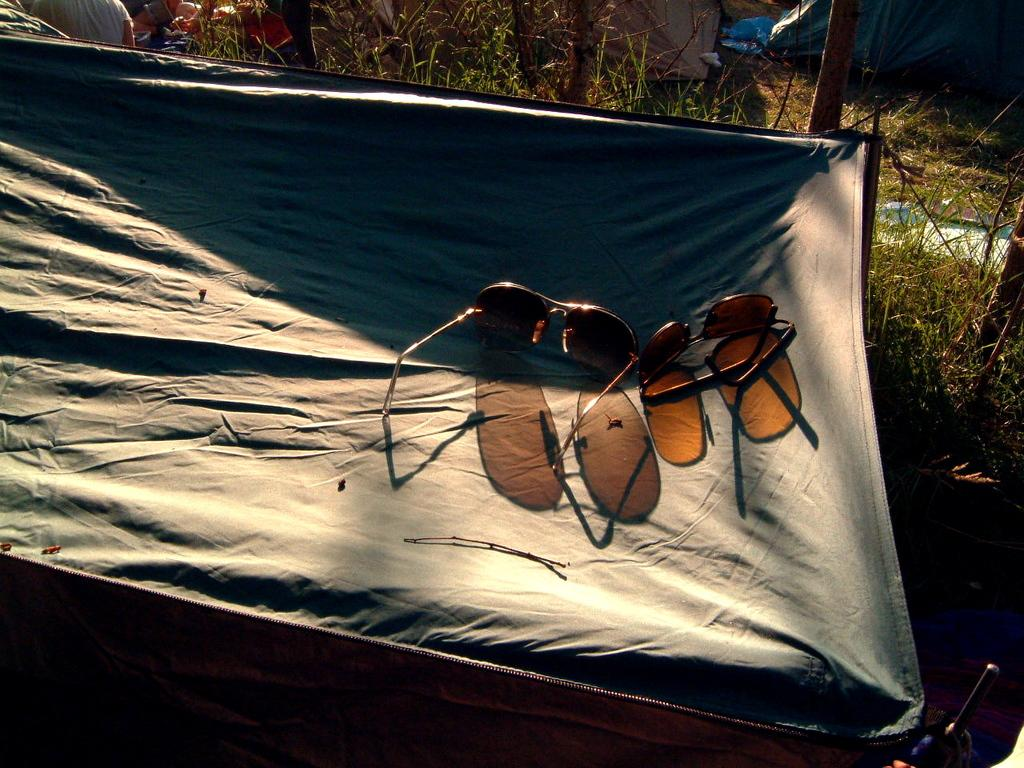What type of eyewear is present in the image? There are goggles in the image. What can be seen in the background of the image? The background of the image includes grass. What type of silverware is visible in the image? There is no silverware present in the image; it only features goggles and grass in the background. 